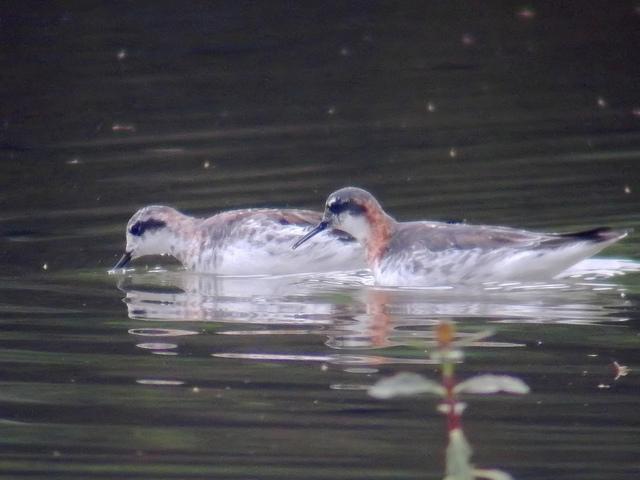How many birds are in the photo?
Give a very brief answer. 2. 